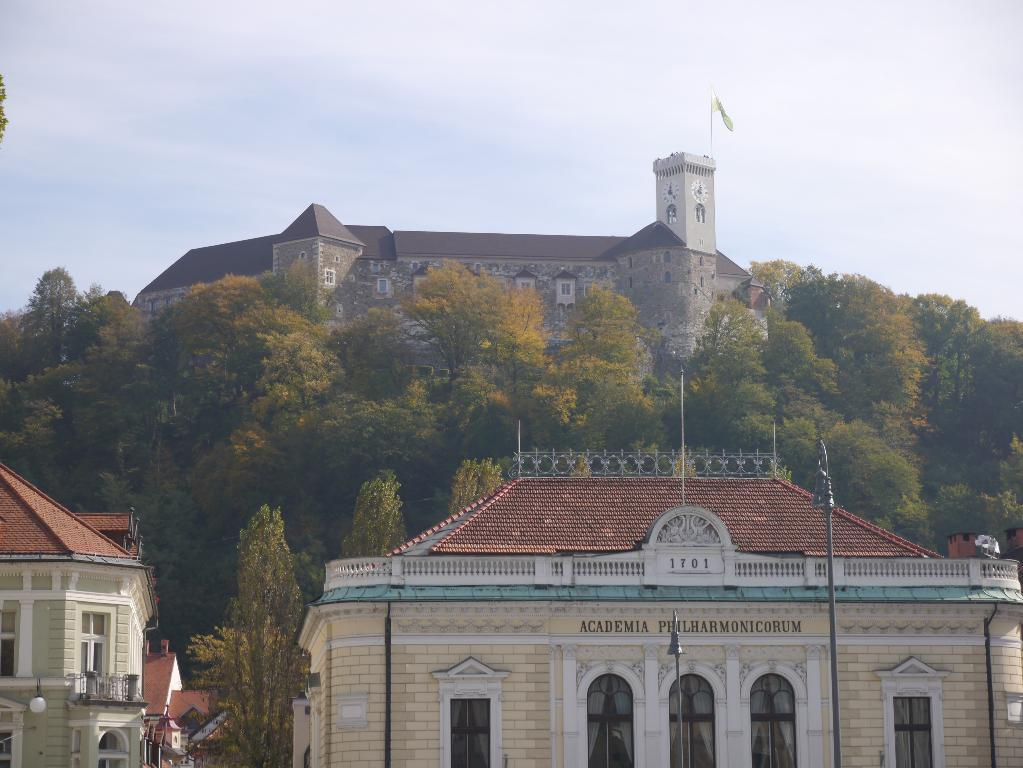What type of structures can be seen in the image? There are buildings in the image. What type of vegetation is present in the image? There are trees in the image. What type of push can be observed in the image? There is no push present in the image; it is a still image of buildings and trees. 